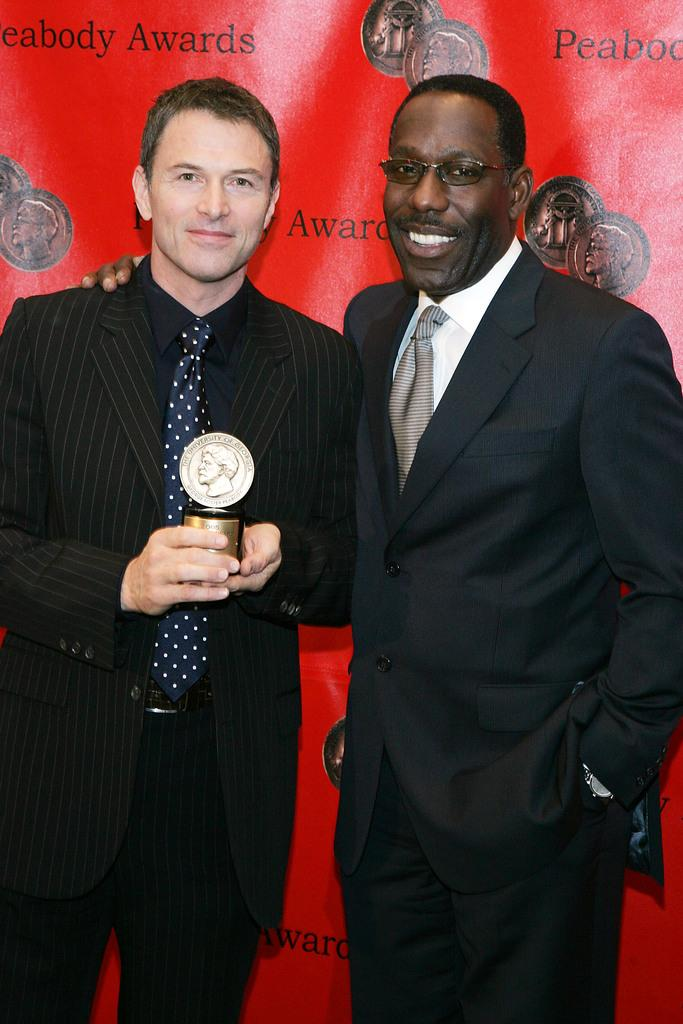How many people are in the image? There are two men in the image. What are the men wearing? Both men are wearing suits. What is one of the men holding? One of the men is holding an award. What type of rhythm can be heard in the background of the image? There is no audible rhythm in the image, as it is a still photograph. 